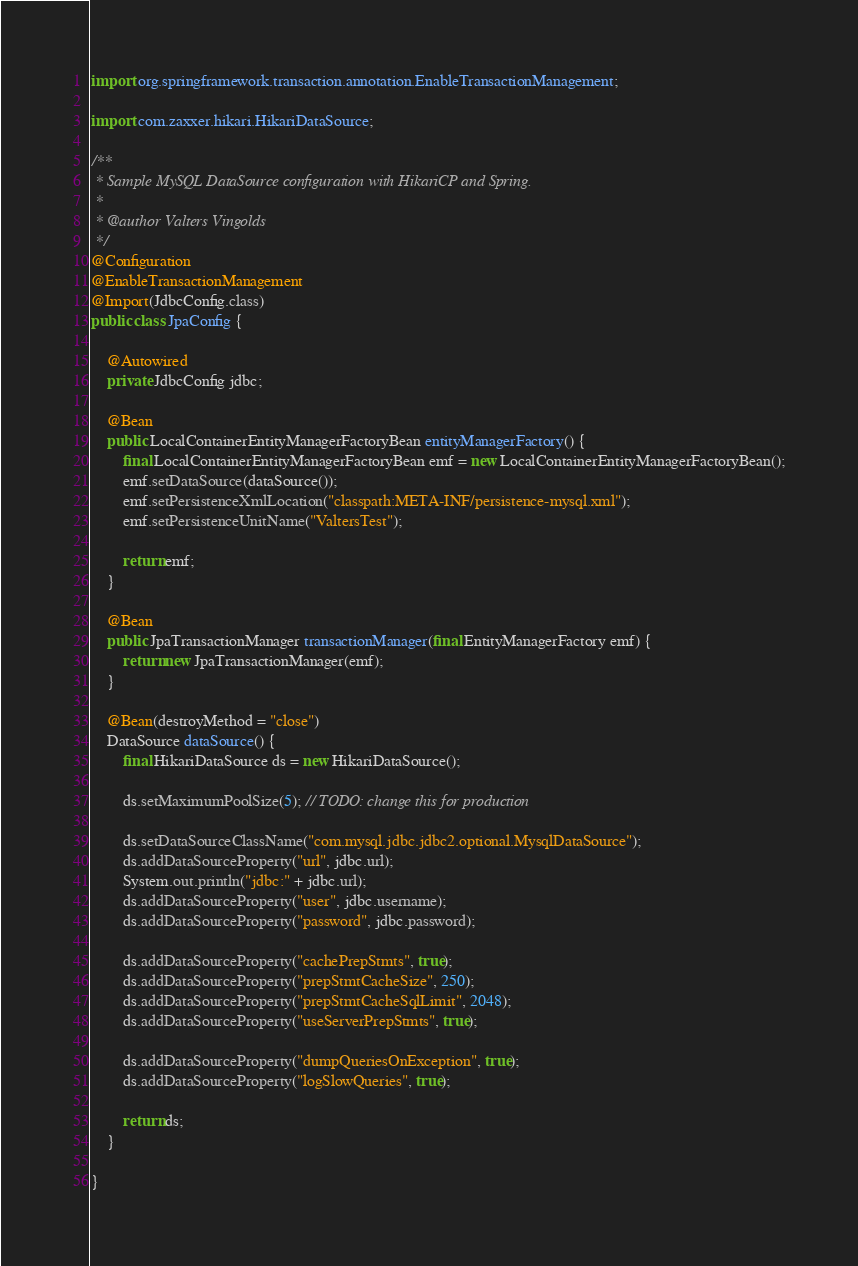Convert code to text. <code><loc_0><loc_0><loc_500><loc_500><_Java_>import org.springframework.transaction.annotation.EnableTransactionManagement;

import com.zaxxer.hikari.HikariDataSource;

/**
 * Sample MySQL DataSource configuration with HikariCP and Spring.
 *
 * @author Valters Vingolds
 */
@Configuration
@EnableTransactionManagement
@Import(JdbcConfig.class)
public class JpaConfig {

    @Autowired
    private JdbcConfig jdbc;

    @Bean
    public LocalContainerEntityManagerFactoryBean entityManagerFactory() {
        final LocalContainerEntityManagerFactoryBean emf = new LocalContainerEntityManagerFactoryBean();
        emf.setDataSource(dataSource());
        emf.setPersistenceXmlLocation("classpath:META-INF/persistence-mysql.xml");
        emf.setPersistenceUnitName("ValtersTest");

        return emf;
    }

    @Bean
    public JpaTransactionManager transactionManager(final EntityManagerFactory emf) {
        return new JpaTransactionManager(emf);
    }

    @Bean(destroyMethod = "close")
    DataSource dataSource() {
        final HikariDataSource ds = new HikariDataSource();

        ds.setMaximumPoolSize(5); // TODO: change this for production

        ds.setDataSourceClassName("com.mysql.jdbc.jdbc2.optional.MysqlDataSource");
        ds.addDataSourceProperty("url", jdbc.url);
        System.out.println("jdbc:" + jdbc.url);
        ds.addDataSourceProperty("user", jdbc.username);
        ds.addDataSourceProperty("password", jdbc.password);

        ds.addDataSourceProperty("cachePrepStmts", true);
        ds.addDataSourceProperty("prepStmtCacheSize", 250);
        ds.addDataSourceProperty("prepStmtCacheSqlLimit", 2048);
        ds.addDataSourceProperty("useServerPrepStmts", true);

        ds.addDataSourceProperty("dumpQueriesOnException", true);
        ds.addDataSourceProperty("logSlowQueries", true);

        return ds;
    }

}
</code> 